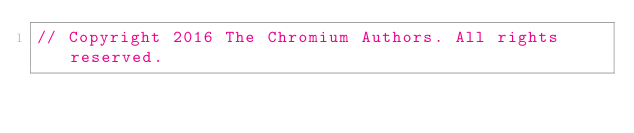Convert code to text. <code><loc_0><loc_0><loc_500><loc_500><_ObjectiveC_>// Copyright 2016 The Chromium Authors. All rights reserved.</code> 